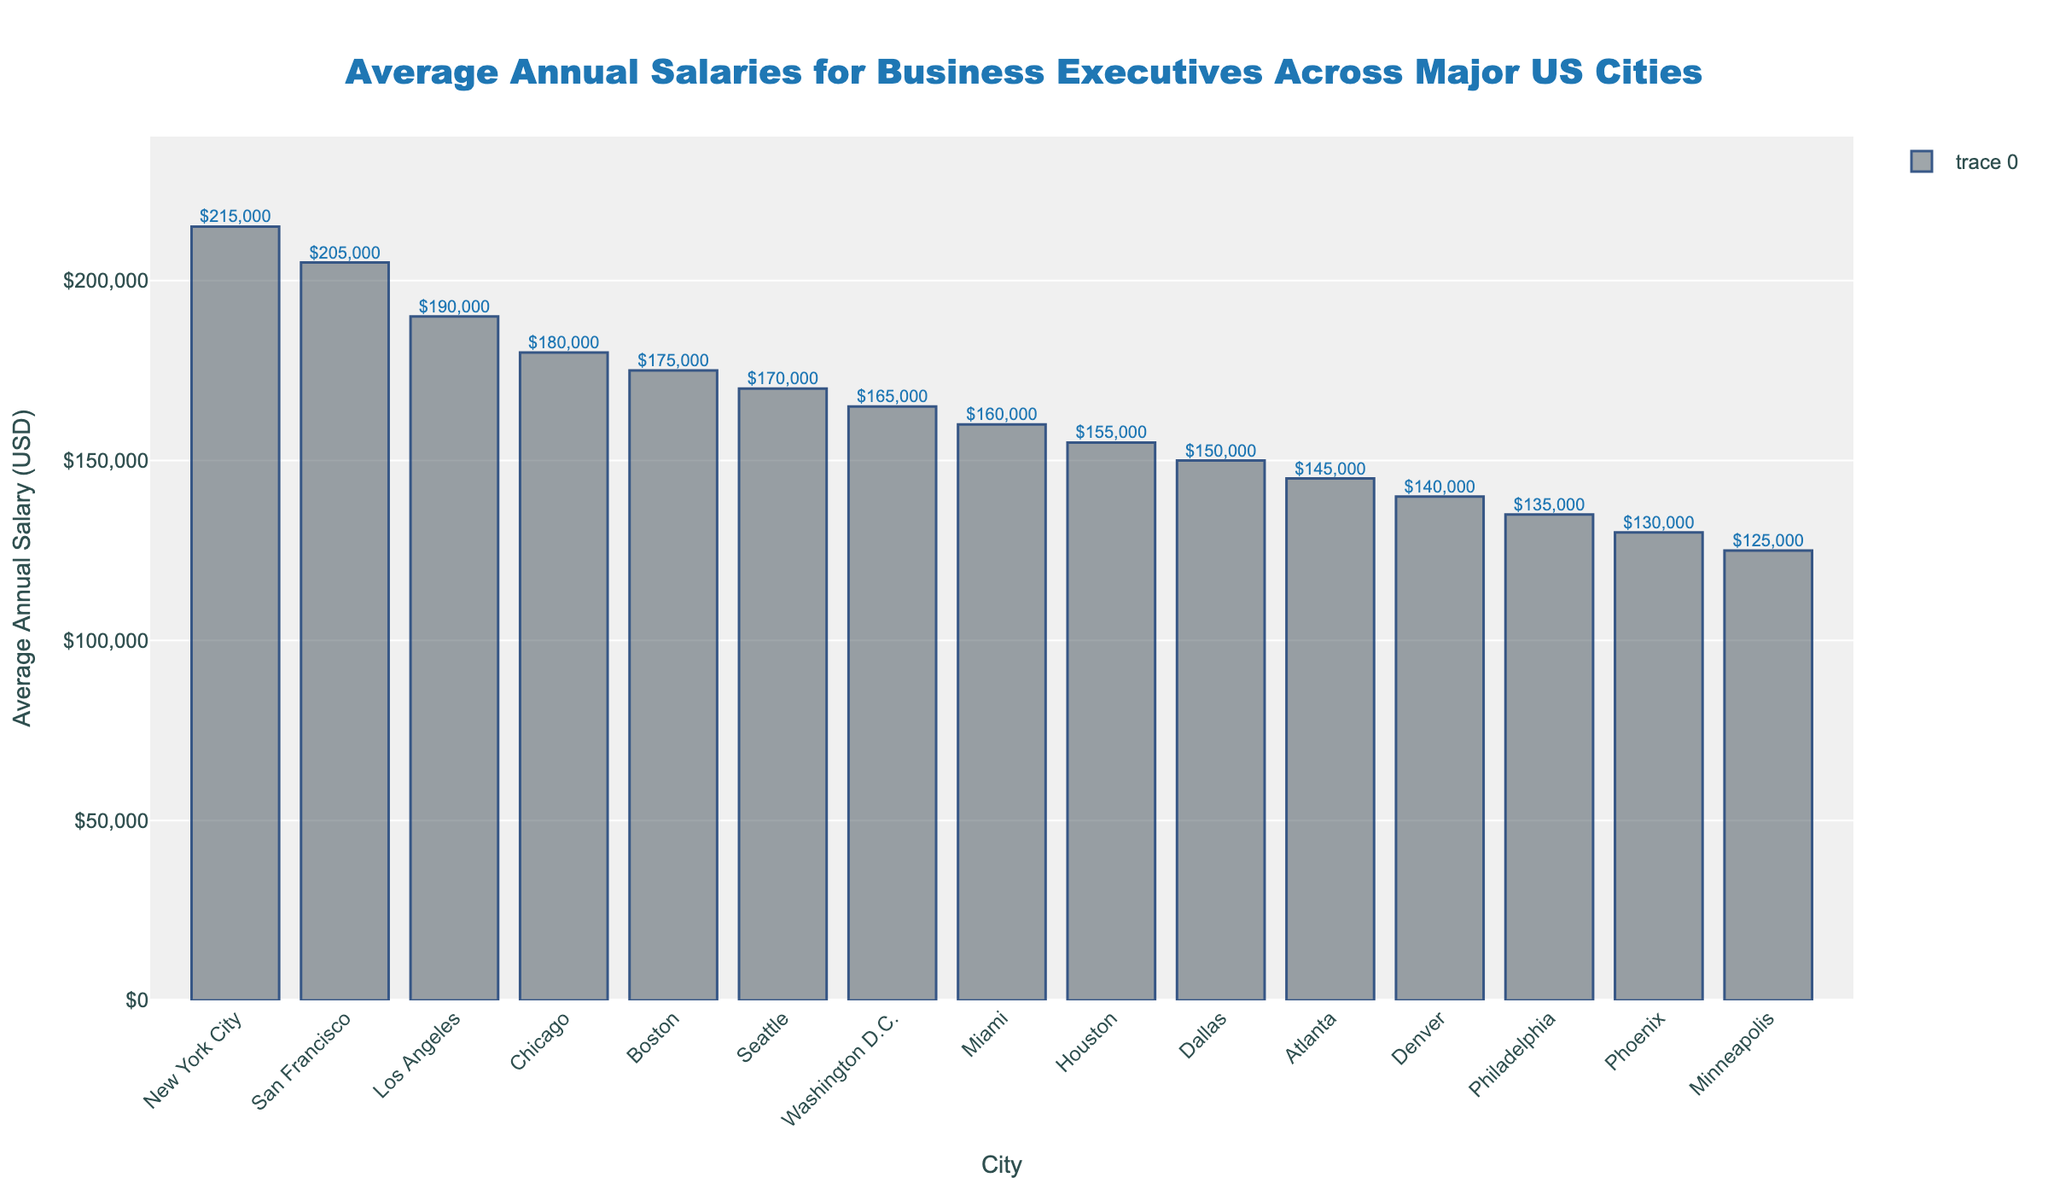Which city has the highest average annual salary for business executives? Observe the height of the bars and identify the tallest one. The city with the tallest bar is New York City.
Answer: New York City Which city has a higher average annual salary for business executives, San Francisco or Los Angeles? Compare the heights of the bars for San Francisco and Los Angeles. San Francisco's bar is higher than Los Angeles's.
Answer: San Francisco What is the difference in average annual salary between the highest and lowest earning cities? Subtract the salary of Minneapolis from New York City: 215000 - 125000 = 90000
Answer: $90,000 How many cities have an average annual salary of more than $180,000? Identify the bars that exceed the $180,000 mark. The cities are New York City, San Francisco, and Los Angeles.
Answer: 3 What is the combined average annual salary of Chicago and Boston? Add the average salaries of Chicago and Boston: 180000 + 175000 = 355000
Answer: $355,000 What is the average annual salary difference between Miami and Houston? Subtract Houston's salary from Miami's: 160000 - 155000 = 5000
Answer: $5,000 Which two cities have the closest average annual salaries and what are these salaries? Compare the salaries of the cities to find the closest pair. Washington D.C. and Miami have the closest salaries with $165,000 and $160,000 respectively.
Answer: Washington D.C. and Miami, $165,000 and $160,000 Which city has the lower average annual salary, Dallas or Atlanta? Compare the heights of the bars for Dallas and Atlanta. Atlanta's bar is lower than Dallas's.
Answer: Atlanta What is the difference between the average annual salaries of the city with the third highest salary and the city with the third lowest salary? Identify the cities: Los Angeles (third highest) and Denver (third lowest). Subtract Denver's salary from Los Angeles's: 190000 - 140000 = 50000
Answer: $50,000 How much higher is the average annual salary of New York City compared to Phoenix? Subtract Phoenix's salary from New York City's: 215000 - 130000 = 85000
Answer: $85,000 